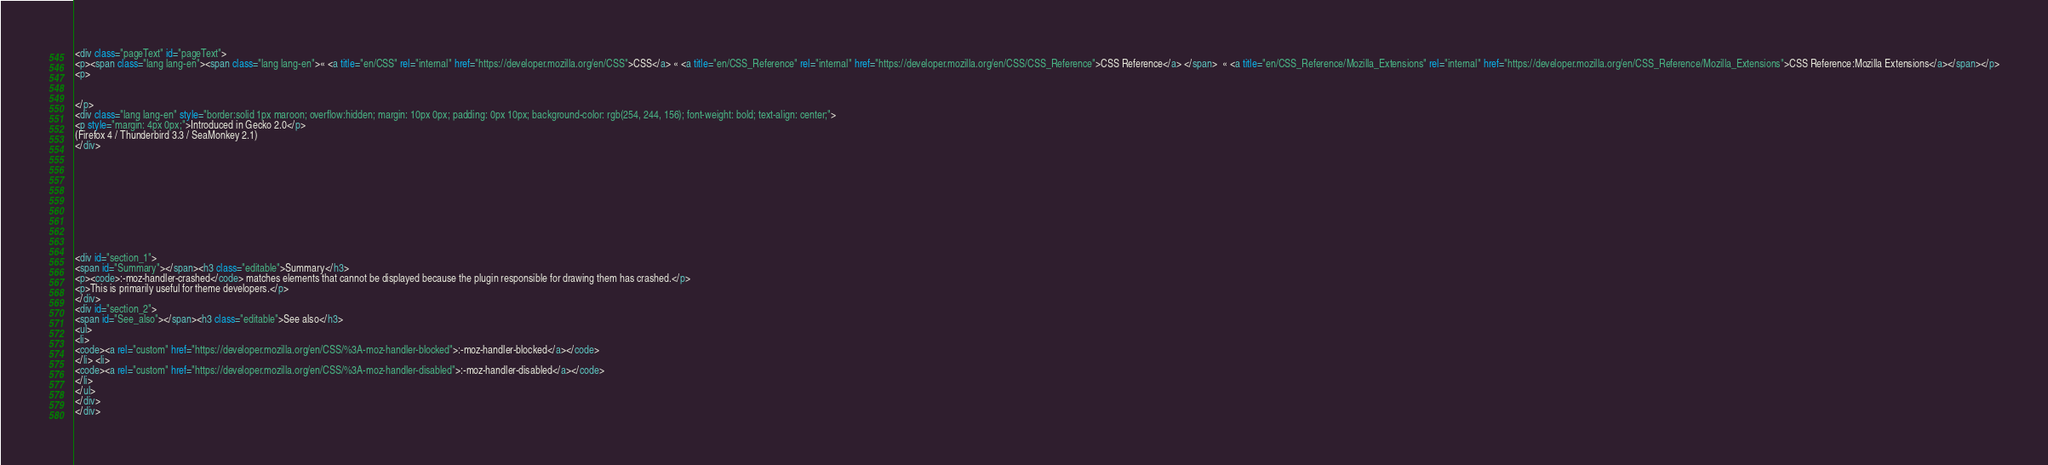<code> <loc_0><loc_0><loc_500><loc_500><_HTML_><div class="pageText" id="pageText">
<p><span class="lang lang-en"><span class="lang lang-en">« <a title="en/CSS" rel="internal" href="https://developer.mozilla.org/en/CSS">CSS</a> « <a title="en/CSS_Reference" rel="internal" href="https://developer.mozilla.org/en/CSS/CSS_Reference">CSS Reference</a> </span>  « <a title="en/CSS_Reference/Mozilla_Extensions" rel="internal" href="https://developer.mozilla.org/en/CSS_Reference/Mozilla_Extensions">CSS Reference:Mozilla Extensions</a></span></p>
<p>


</p>
<div class="lang lang-en" style="border:solid 1px maroon; overflow:hidden; margin: 10px 0px; padding: 0px 10px; background-color: rgb(254, 244, 156); font-weight: bold; text-align: center;">
<p style="margin: 4px 0px;">Introduced in Gecko 2.0</p>
(Firefox 4 / Thunderbird 3.3 / SeaMonkey 2.1)
</div>










<div id="section_1">
<span id="Summary"></span><h3 class="editable">Summary</h3>
<p><code>:-moz-handler-crashed</code> matches elements that cannot be displayed because the plugin responsible for drawing them has crashed.</p>
<p>This is primarily useful for theme developers.</p>
</div>
<div id="section_2">
<span id="See_also"></span><h3 class="editable">See also</h3>
<ul>
<li>
<code><a rel="custom" href="https://developer.mozilla.org/en/CSS/%3A-moz-handler-blocked">:-moz-handler-blocked</a></code>
</li> <li>
<code><a rel="custom" href="https://developer.mozilla.org/en/CSS/%3A-moz-handler-disabled">:-moz-handler-disabled</a></code>
</li>
</ul>
</div>
</div></code> 